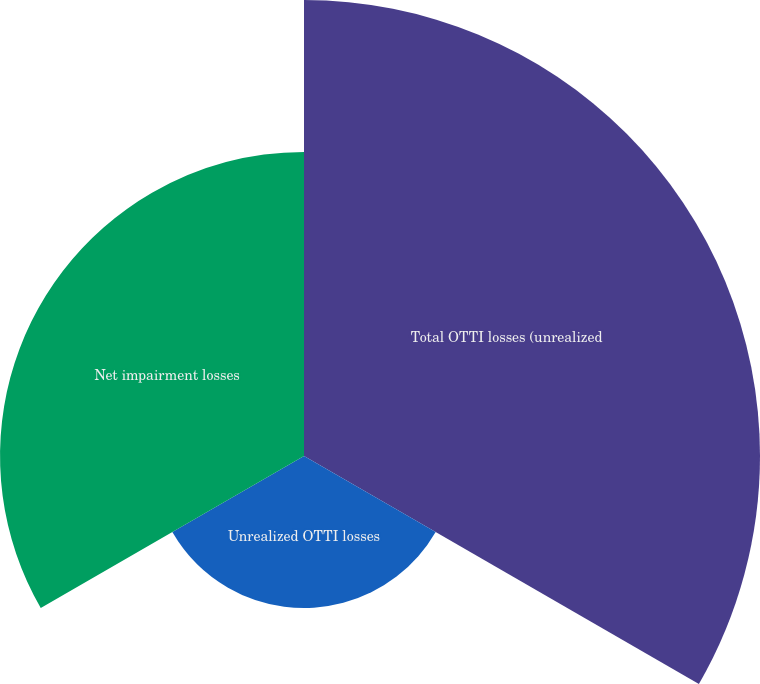Convert chart. <chart><loc_0><loc_0><loc_500><loc_500><pie_chart><fcel>Total OTTI losses (unrealized<fcel>Unrealized OTTI losses<fcel>Net impairment losses<nl><fcel>50.0%<fcel>16.67%<fcel>33.33%<nl></chart> 